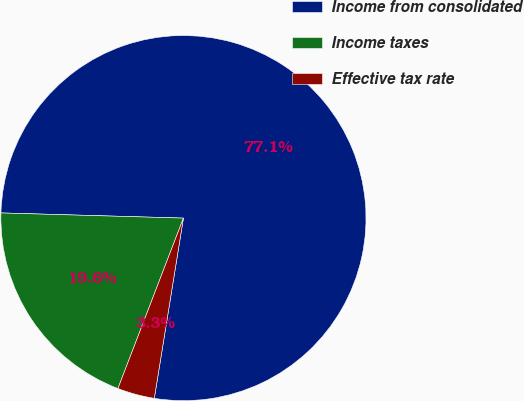Convert chart. <chart><loc_0><loc_0><loc_500><loc_500><pie_chart><fcel>Income from consolidated<fcel>Income taxes<fcel>Effective tax rate<nl><fcel>77.1%<fcel>19.61%<fcel>3.29%<nl></chart> 